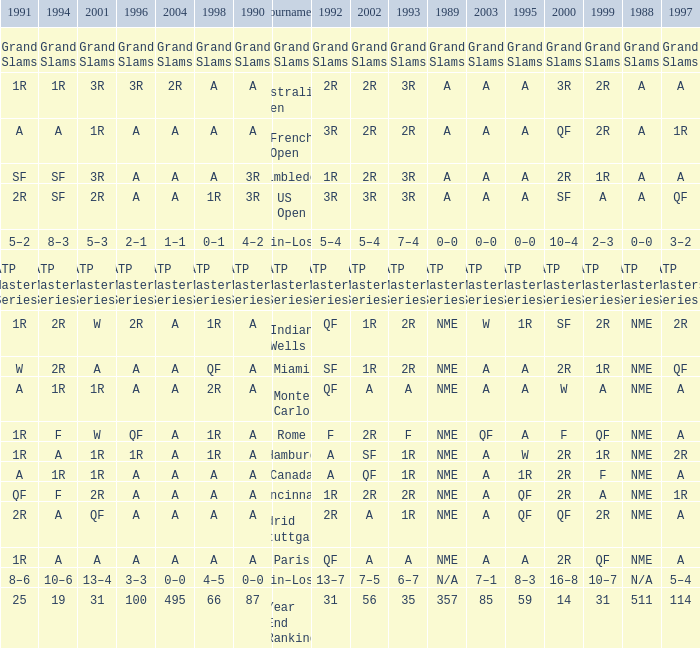What shows for 1988 when 1994 shows 10–6? N/A. I'm looking to parse the entire table for insights. Could you assist me with that? {'header': ['1991', '1994', '2001', '1996', '2004', '1998', '1990', 'Tournament', '1992', '2002', '1993', '1989', '2003', '1995', '2000', '1999', '1988', '1997'], 'rows': [['Grand Slams', 'Grand Slams', 'Grand Slams', 'Grand Slams', 'Grand Slams', 'Grand Slams', 'Grand Slams', 'Grand Slams', 'Grand Slams', 'Grand Slams', 'Grand Slams', 'Grand Slams', 'Grand Slams', 'Grand Slams', 'Grand Slams', 'Grand Slams', 'Grand Slams', 'Grand Slams'], ['1R', '1R', '3R', '3R', '2R', 'A', 'A', 'Australian Open', '2R', '2R', '3R', 'A', 'A', 'A', '3R', '2R', 'A', 'A'], ['A', 'A', '1R', 'A', 'A', 'A', 'A', 'French Open', '3R', '2R', '2R', 'A', 'A', 'A', 'QF', '2R', 'A', '1R'], ['SF', 'SF', '3R', 'A', 'A', 'A', '3R', 'Wimbledon', '1R', '2R', '3R', 'A', 'A', 'A', '2R', '1R', 'A', 'A'], ['2R', 'SF', '2R', 'A', 'A', '1R', '3R', 'US Open', '3R', '3R', '3R', 'A', 'A', 'A', 'SF', 'A', 'A', 'QF'], ['5–2', '8–3', '5–3', '2–1', '1–1', '0–1', '4–2', 'Win–Loss', '5–4', '5–4', '7–4', '0–0', '0–0', '0–0', '10–4', '2–3', '0–0', '3–2'], ['ATP Masters Series', 'ATP Masters Series', 'ATP Masters Series', 'ATP Masters Series', 'ATP Masters Series', 'ATP Masters Series', 'ATP Masters Series', 'ATP Masters Series', 'ATP Masters Series', 'ATP Masters Series', 'ATP Masters Series', 'ATP Masters Series', 'ATP Masters Series', 'ATP Masters Series', 'ATP Masters Series', 'ATP Masters Series', 'ATP Masters Series', 'ATP Masters Series'], ['1R', '2R', 'W', '2R', 'A', '1R', 'A', 'Indian Wells', 'QF', '1R', '2R', 'NME', 'W', '1R', 'SF', '2R', 'NME', '2R'], ['W', '2R', 'A', 'A', 'A', 'QF', 'A', 'Miami', 'SF', '1R', '2R', 'NME', 'A', 'A', '2R', '1R', 'NME', 'QF'], ['A', '1R', '1R', 'A', 'A', '2R', 'A', 'Monte Carlo', 'QF', 'A', 'A', 'NME', 'A', 'A', 'W', 'A', 'NME', 'A'], ['1R', 'F', 'W', 'QF', 'A', '1R', 'A', 'Rome', 'F', '2R', 'F', 'NME', 'QF', 'A', 'F', 'QF', 'NME', 'A'], ['1R', 'A', '1R', '1R', 'A', '1R', 'A', 'Hamburg', 'A', 'SF', '1R', 'NME', 'A', 'W', '2R', '1R', 'NME', '2R'], ['A', '1R', '1R', 'A', 'A', 'A', 'A', 'Canada', 'A', 'QF', '1R', 'NME', 'A', '1R', '2R', 'F', 'NME', 'A'], ['QF', 'F', '2R', 'A', 'A', 'A', 'A', 'Cincinnati', '1R', '2R', '2R', 'NME', 'A', 'QF', '2R', 'A', 'NME', '1R'], ['2R', 'A', 'QF', 'A', 'A', 'A', 'A', 'Madrid (Stuttgart)', '2R', 'A', '1R', 'NME', 'A', 'QF', 'QF', '2R', 'NME', 'A'], ['1R', 'A', 'A', 'A', 'A', 'A', 'A', 'Paris', 'QF', 'A', 'A', 'NME', 'A', 'A', '2R', 'QF', 'NME', 'A'], ['8–6', '10–6', '13–4', '3–3', '0–0', '4–5', '0–0', 'Win–Loss', '13–7', '7–5', '6–7', 'N/A', '7–1', '8–3', '16–8', '10–7', 'N/A', '5–4'], ['25', '19', '31', '100', '495', '66', '87', 'Year End Ranking', '31', '56', '35', '357', '85', '59', '14', '31', '511', '114']]} 